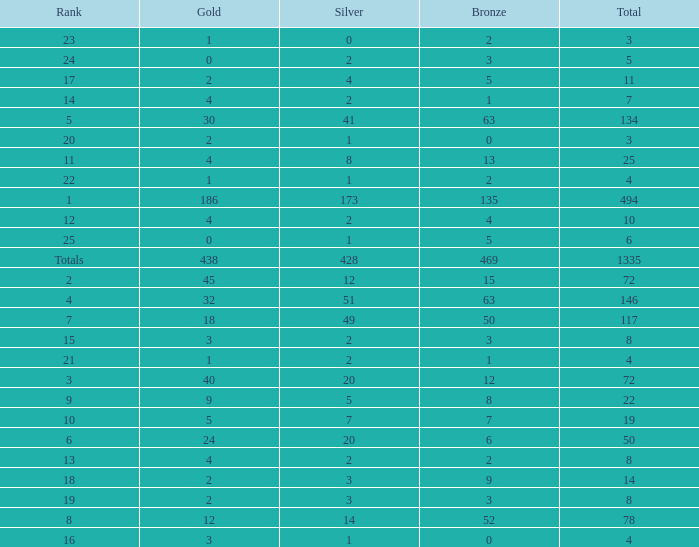What is the total amount of gold medals when there were more than 20 silvers and there were 135 bronze medals? 1.0. 